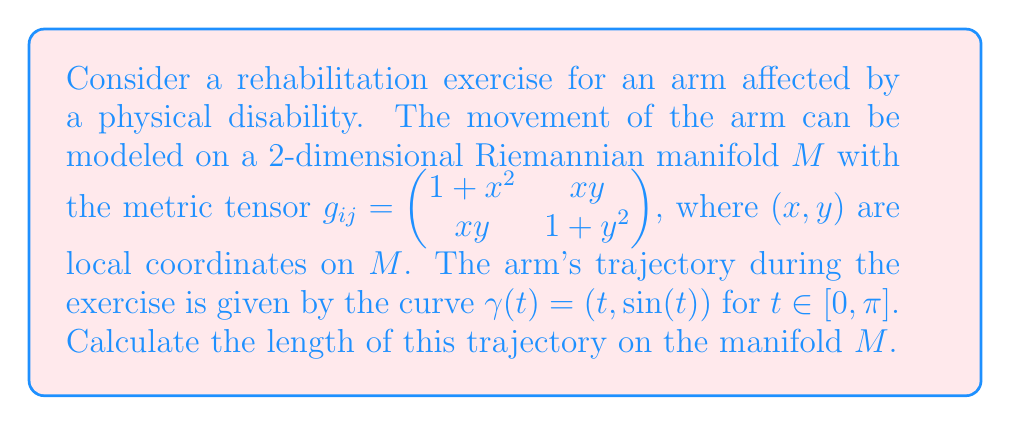Provide a solution to this math problem. To solve this problem, we'll follow these steps:

1) The length of a curve $\gamma(t) = (x(t), y(t))$ on a Riemannian manifold is given by the formula:

   $$L = \int_a^b \sqrt{g_{ij} \frac{d\gamma^i}{dt} \frac{d\gamma^j}{dt}} dt$$

2) In our case, $\gamma(t) = (t, \sin(t))$, so $\frac{d\gamma^1}{dt} = 1$ and $\frac{d\gamma^2}{dt} = \cos(t)$.

3) Substituting these into the formula:

   $$L = \int_0^\pi \sqrt{g_{11} \cdot 1^2 + 2g_{12} \cdot 1 \cdot \cos(t) + g_{22} \cdot \cos^2(t)} dt$$

4) Now, let's substitute the components of the metric tensor:

   $$L = \int_0^\pi \sqrt{(1+t^2) \cdot 1^2 + 2(t\sin(t)) \cdot 1 \cdot \cos(t) + (1+\sin^2(t)) \cdot \cos^2(t)} dt$$

5) Simplify:

   $$L = \int_0^\pi \sqrt{1+t^2 + 2t\sin(t)\cos(t) + \cos^2(t) + \sin^2(t)\cos^2(t)} dt$$

6) Recall that $\sin(2t) = 2\sin(t)\cos(t)$ and $\sin^2(t) + \cos^2(t) = 1$:

   $$L = \int_0^\pi \sqrt{1+t^2 + t\sin(2t) + 1} dt$$

7) Simplify further:

   $$L = \int_0^\pi \sqrt{2+t^2 + t\sin(2t)} dt$$

8) This integral doesn't have a simple closed-form solution, so we need to evaluate it numerically.
Answer: The length of the trajectory is approximately 4.5415 units, obtained by numerical integration of the expression:

$$L = \int_0^\pi \sqrt{2+t^2 + t\sin(2t)} dt$$ 